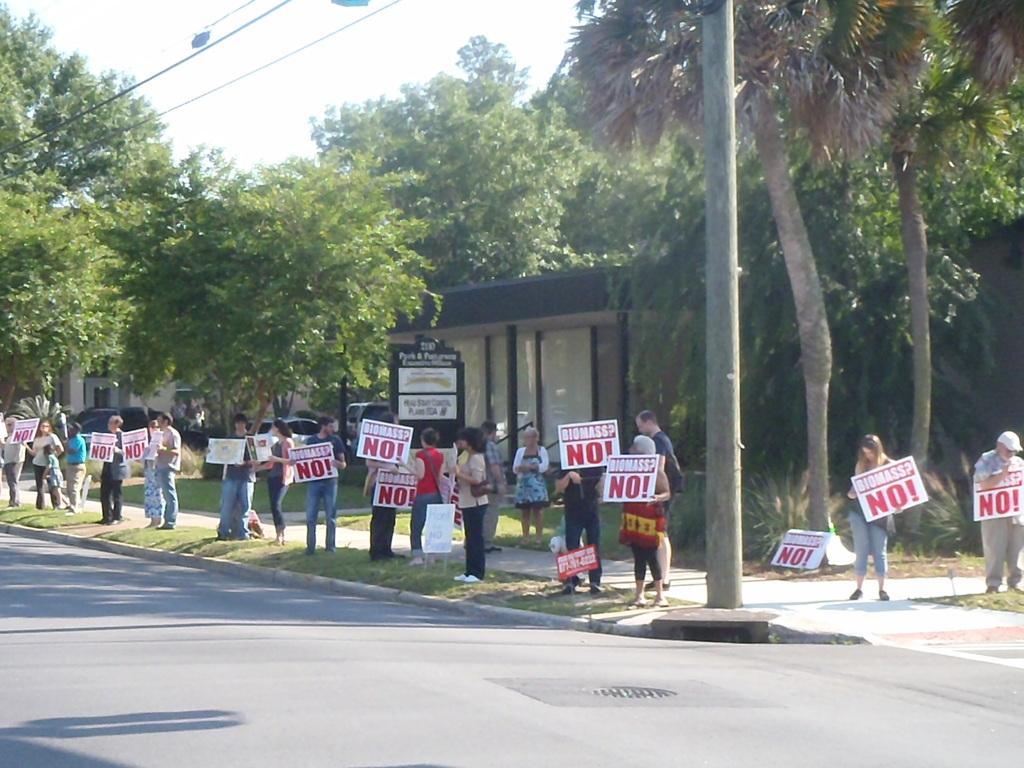What are they protesting against?
Ensure brevity in your answer.  Biomass. What do all the signs say  in bold?
Provide a succinct answer. No!. 